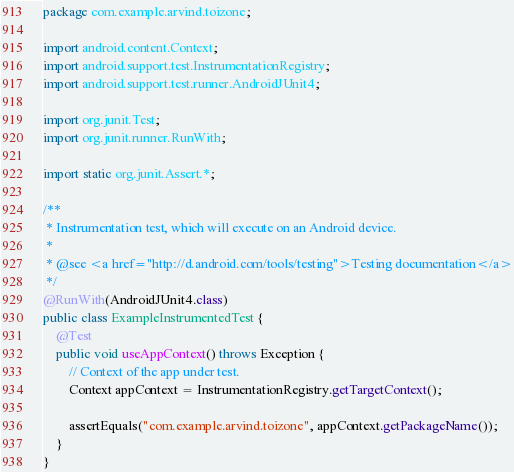Convert code to text. <code><loc_0><loc_0><loc_500><loc_500><_Java_>package com.example.arvind.toizone;

import android.content.Context;
import android.support.test.InstrumentationRegistry;
import android.support.test.runner.AndroidJUnit4;

import org.junit.Test;
import org.junit.runner.RunWith;

import static org.junit.Assert.*;

/**
 * Instrumentation test, which will execute on an Android device.
 *
 * @see <a href="http://d.android.com/tools/testing">Testing documentation</a>
 */
@RunWith(AndroidJUnit4.class)
public class ExampleInstrumentedTest {
    @Test
    public void useAppContext() throws Exception {
        // Context of the app under test.
        Context appContext = InstrumentationRegistry.getTargetContext();

        assertEquals("com.example.arvind.toizone", appContext.getPackageName());
    }
}
</code> 